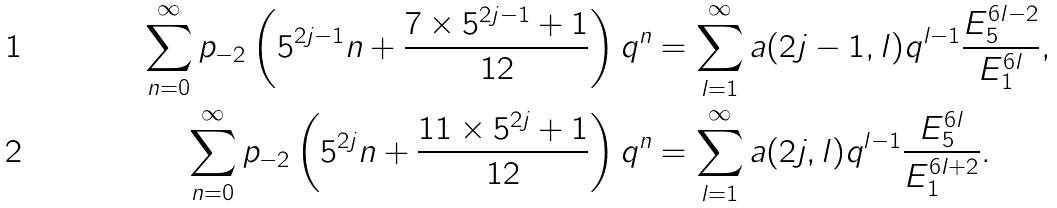<formula> <loc_0><loc_0><loc_500><loc_500>\sum _ { n = 0 } ^ { \infty } p _ { - 2 } \left ( 5 ^ { 2 j - 1 } n + \frac { 7 \times 5 ^ { 2 j - 1 } + 1 } { 1 2 } \right ) q ^ { n } & = \sum _ { l = 1 } ^ { \infty } a ( 2 j - 1 , l ) q ^ { l - 1 } \frac { E _ { 5 } ^ { 6 l - 2 } } { E _ { 1 } ^ { 6 l } } , \\ \sum _ { n = 0 } ^ { \infty } p _ { - 2 } \left ( 5 ^ { 2 j } n + \frac { 1 1 \times 5 ^ { 2 j } + 1 } { 1 2 } \right ) q ^ { n } & = \sum _ { l = 1 } ^ { \infty } a ( 2 j , l ) q ^ { l - 1 } \frac { E _ { 5 } ^ { 6 l } } { E _ { 1 } ^ { 6 l + 2 } } .</formula> 